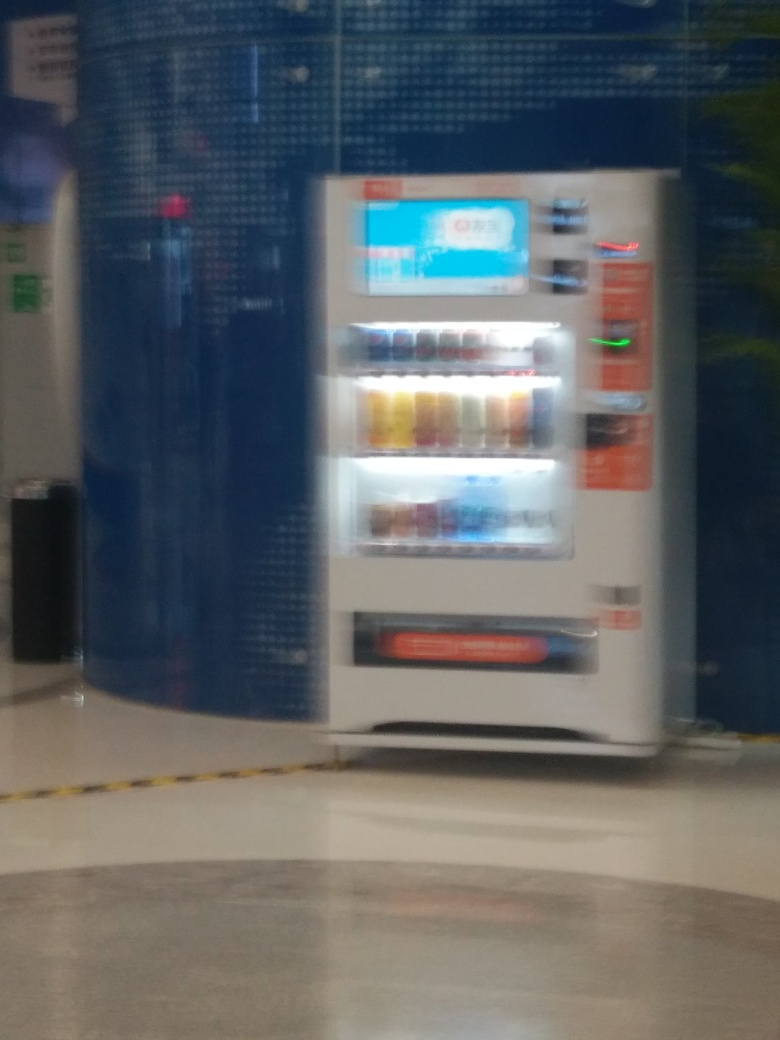How would you describe the environment this vending machine is in? The vending machine is situated in an indoor setting with tiled flooring, and it's placed against a wall decorated with a blue-tiled mosaic pattern, which suggests a public or semi-public space such as a mall, airport, or transit station. 